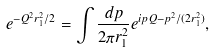<formula> <loc_0><loc_0><loc_500><loc_500>e ^ { - Q ^ { 2 } r _ { 1 } ^ { 2 } / 2 } = \int \frac { d { p } } { 2 \pi r _ { 1 } ^ { 2 } } e ^ { i { p Q } - p ^ { 2 } / ( 2 r _ { 1 } ^ { 2 } ) } ,</formula> 